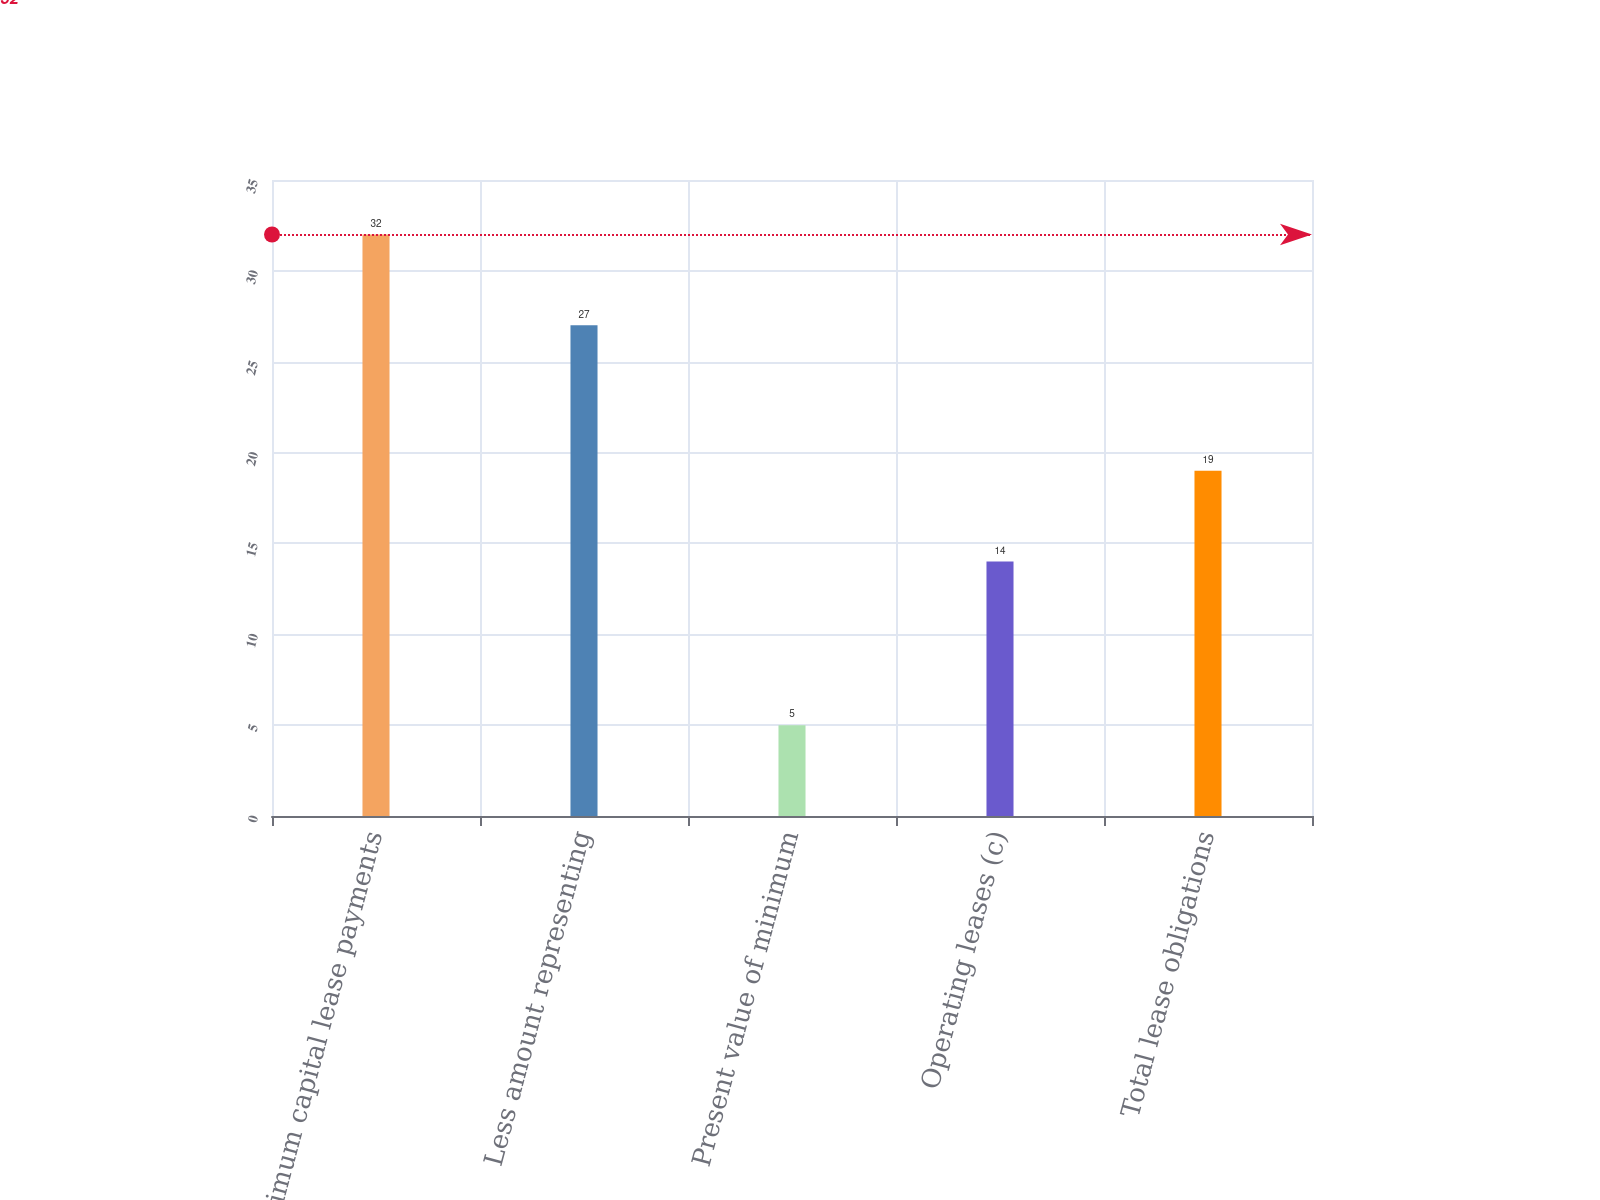Convert chart to OTSL. <chart><loc_0><loc_0><loc_500><loc_500><bar_chart><fcel>Minimum capital lease payments<fcel>Less amount representing<fcel>Present value of minimum<fcel>Operating leases (c)<fcel>Total lease obligations<nl><fcel>32<fcel>27<fcel>5<fcel>14<fcel>19<nl></chart> 